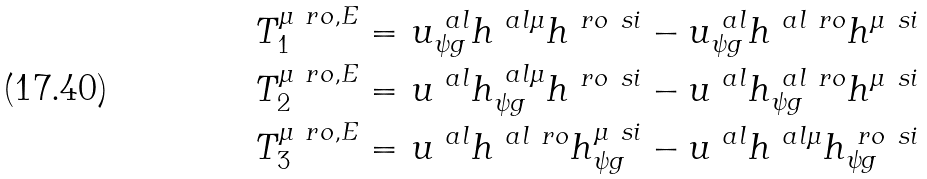<formula> <loc_0><loc_0><loc_500><loc_500>T _ { 1 } ^ { \mu \ r o , E } = & \ u ^ { \ a l } _ { \psi g } h ^ { \ a l \mu } h ^ { \ r o \ s i } - u ^ { \ a l } _ { \psi g } h ^ { \ a l \ r o } h ^ { \mu \ s i } \\ T _ { 2 } ^ { \mu \ r o , E } = & \ u ^ { \ a l } h ^ { \ a l \mu } _ { \psi g } h ^ { \ r o \ s i } - u ^ { \ a l } h ^ { \ a l \ r o } _ { \psi g } h ^ { \mu \ s i } \\ T _ { 3 } ^ { \mu \ r o , E } = & \ u ^ { \ a l } h ^ { \ a l \ r o } h ^ { \mu \ s i } _ { \psi g } - u ^ { \ a l } h ^ { \ a l \mu } h ^ { \ r o \ s i } _ { \psi g } \\</formula> 